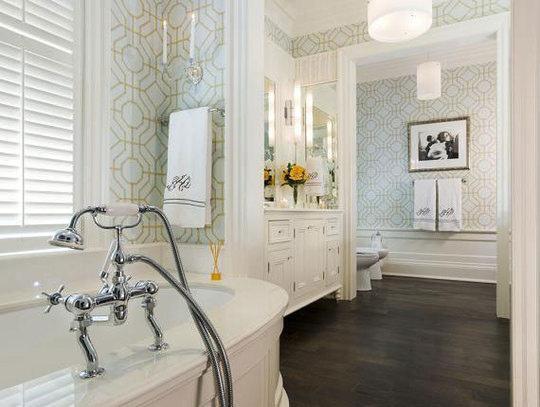How many towels are there?
Give a very brief answer. 3. 